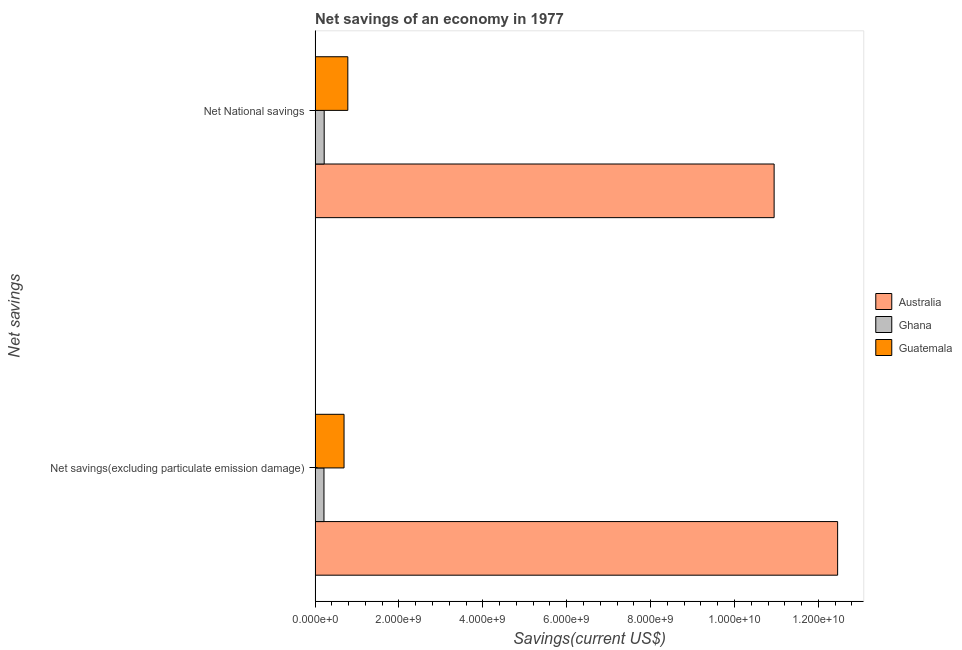How many different coloured bars are there?
Ensure brevity in your answer.  3. How many groups of bars are there?
Your answer should be very brief. 2. How many bars are there on the 1st tick from the top?
Your answer should be compact. 3. What is the label of the 2nd group of bars from the top?
Your answer should be compact. Net savings(excluding particulate emission damage). What is the net national savings in Ghana?
Offer a terse response. 2.17e+08. Across all countries, what is the maximum net national savings?
Give a very brief answer. 1.09e+1. Across all countries, what is the minimum net national savings?
Offer a very short reply. 2.17e+08. In which country was the net savings(excluding particulate emission damage) maximum?
Your answer should be compact. Australia. In which country was the net savings(excluding particulate emission damage) minimum?
Keep it short and to the point. Ghana. What is the total net savings(excluding particulate emission damage) in the graph?
Your answer should be compact. 1.34e+1. What is the difference between the net national savings in Australia and that in Ghana?
Offer a terse response. 1.07e+1. What is the difference between the net savings(excluding particulate emission damage) in Australia and the net national savings in Ghana?
Your response must be concise. 1.22e+1. What is the average net savings(excluding particulate emission damage) per country?
Provide a succinct answer. 4.45e+09. What is the difference between the net national savings and net savings(excluding particulate emission damage) in Australia?
Make the answer very short. -1.51e+09. What is the ratio of the net national savings in Ghana to that in Guatemala?
Give a very brief answer. 0.28. Is the net savings(excluding particulate emission damage) in Australia less than that in Guatemala?
Make the answer very short. No. In how many countries, is the net savings(excluding particulate emission damage) greater than the average net savings(excluding particulate emission damage) taken over all countries?
Your answer should be compact. 1. What does the 3rd bar from the bottom in Net savings(excluding particulate emission damage) represents?
Your answer should be very brief. Guatemala. Are all the bars in the graph horizontal?
Keep it short and to the point. Yes. What is the difference between two consecutive major ticks on the X-axis?
Keep it short and to the point. 2.00e+09. Are the values on the major ticks of X-axis written in scientific E-notation?
Offer a terse response. Yes. Does the graph contain grids?
Make the answer very short. No. Where does the legend appear in the graph?
Give a very brief answer. Center right. How are the legend labels stacked?
Provide a succinct answer. Vertical. What is the title of the graph?
Keep it short and to the point. Net savings of an economy in 1977. Does "Middle income" appear as one of the legend labels in the graph?
Provide a short and direct response. No. What is the label or title of the X-axis?
Make the answer very short. Savings(current US$). What is the label or title of the Y-axis?
Your response must be concise. Net savings. What is the Savings(current US$) in Australia in Net savings(excluding particulate emission damage)?
Keep it short and to the point. 1.25e+1. What is the Savings(current US$) in Ghana in Net savings(excluding particulate emission damage)?
Your answer should be very brief. 2.11e+08. What is the Savings(current US$) of Guatemala in Net savings(excluding particulate emission damage)?
Your response must be concise. 6.90e+08. What is the Savings(current US$) in Australia in Net National savings?
Give a very brief answer. 1.09e+1. What is the Savings(current US$) in Ghana in Net National savings?
Provide a succinct answer. 2.17e+08. What is the Savings(current US$) in Guatemala in Net National savings?
Offer a very short reply. 7.80e+08. Across all Net savings, what is the maximum Savings(current US$) of Australia?
Provide a succinct answer. 1.25e+1. Across all Net savings, what is the maximum Savings(current US$) of Ghana?
Ensure brevity in your answer.  2.17e+08. Across all Net savings, what is the maximum Savings(current US$) of Guatemala?
Your answer should be very brief. 7.80e+08. Across all Net savings, what is the minimum Savings(current US$) in Australia?
Your response must be concise. 1.09e+1. Across all Net savings, what is the minimum Savings(current US$) of Ghana?
Make the answer very short. 2.11e+08. Across all Net savings, what is the minimum Savings(current US$) in Guatemala?
Ensure brevity in your answer.  6.90e+08. What is the total Savings(current US$) in Australia in the graph?
Offer a very short reply. 2.34e+1. What is the total Savings(current US$) of Ghana in the graph?
Keep it short and to the point. 4.28e+08. What is the total Savings(current US$) in Guatemala in the graph?
Provide a succinct answer. 1.47e+09. What is the difference between the Savings(current US$) in Australia in Net savings(excluding particulate emission damage) and that in Net National savings?
Your response must be concise. 1.51e+09. What is the difference between the Savings(current US$) in Ghana in Net savings(excluding particulate emission damage) and that in Net National savings?
Your answer should be very brief. -5.32e+06. What is the difference between the Savings(current US$) of Guatemala in Net savings(excluding particulate emission damage) and that in Net National savings?
Your response must be concise. -9.04e+07. What is the difference between the Savings(current US$) in Australia in Net savings(excluding particulate emission damage) and the Savings(current US$) in Ghana in Net National savings?
Your answer should be very brief. 1.22e+1. What is the difference between the Savings(current US$) in Australia in Net savings(excluding particulate emission damage) and the Savings(current US$) in Guatemala in Net National savings?
Your answer should be compact. 1.17e+1. What is the difference between the Savings(current US$) in Ghana in Net savings(excluding particulate emission damage) and the Savings(current US$) in Guatemala in Net National savings?
Keep it short and to the point. -5.69e+08. What is the average Savings(current US$) in Australia per Net savings?
Your answer should be compact. 1.17e+1. What is the average Savings(current US$) of Ghana per Net savings?
Make the answer very short. 2.14e+08. What is the average Savings(current US$) in Guatemala per Net savings?
Offer a very short reply. 7.35e+08. What is the difference between the Savings(current US$) in Australia and Savings(current US$) in Ghana in Net savings(excluding particulate emission damage)?
Provide a short and direct response. 1.22e+1. What is the difference between the Savings(current US$) of Australia and Savings(current US$) of Guatemala in Net savings(excluding particulate emission damage)?
Provide a succinct answer. 1.18e+1. What is the difference between the Savings(current US$) in Ghana and Savings(current US$) in Guatemala in Net savings(excluding particulate emission damage)?
Give a very brief answer. -4.79e+08. What is the difference between the Savings(current US$) of Australia and Savings(current US$) of Ghana in Net National savings?
Provide a short and direct response. 1.07e+1. What is the difference between the Savings(current US$) in Australia and Savings(current US$) in Guatemala in Net National savings?
Give a very brief answer. 1.02e+1. What is the difference between the Savings(current US$) in Ghana and Savings(current US$) in Guatemala in Net National savings?
Your response must be concise. -5.64e+08. What is the ratio of the Savings(current US$) in Australia in Net savings(excluding particulate emission damage) to that in Net National savings?
Offer a very short reply. 1.14. What is the ratio of the Savings(current US$) in Ghana in Net savings(excluding particulate emission damage) to that in Net National savings?
Keep it short and to the point. 0.98. What is the ratio of the Savings(current US$) in Guatemala in Net savings(excluding particulate emission damage) to that in Net National savings?
Offer a very short reply. 0.88. What is the difference between the highest and the second highest Savings(current US$) of Australia?
Make the answer very short. 1.51e+09. What is the difference between the highest and the second highest Savings(current US$) of Ghana?
Give a very brief answer. 5.32e+06. What is the difference between the highest and the second highest Savings(current US$) of Guatemala?
Ensure brevity in your answer.  9.04e+07. What is the difference between the highest and the lowest Savings(current US$) of Australia?
Make the answer very short. 1.51e+09. What is the difference between the highest and the lowest Savings(current US$) of Ghana?
Provide a short and direct response. 5.32e+06. What is the difference between the highest and the lowest Savings(current US$) in Guatemala?
Your answer should be compact. 9.04e+07. 